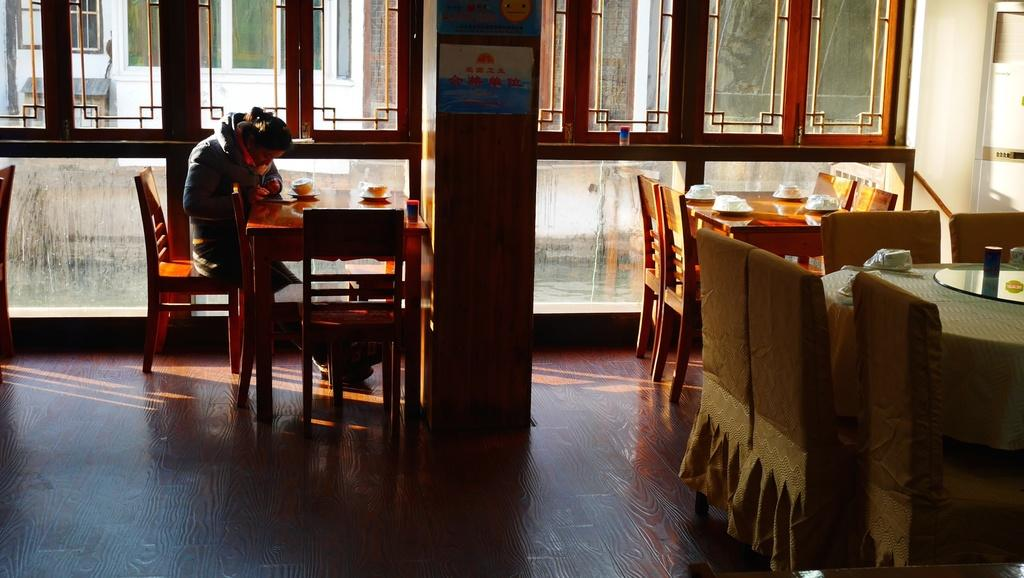What is the woman in the image doing? The woman is sitting on a chair in the image. What objects can be seen on the tables in the image? There are plates and cups on the tables in the image. What architectural feature is present in the image? There is a pillar in the image. What can be seen through the window in the image? The presence of a window suggests that there might be a view of the outdoors or another room. How does the woman contribute to pollution in the image? There is no indication in the image that the woman is contributing to pollution. 